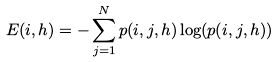Convert formula to latex. <formula><loc_0><loc_0><loc_500><loc_500>E ( i , h ) = - \sum _ { j = 1 } ^ { N } p ( i , j , h ) \log ( p ( i , j , h ) )</formula> 